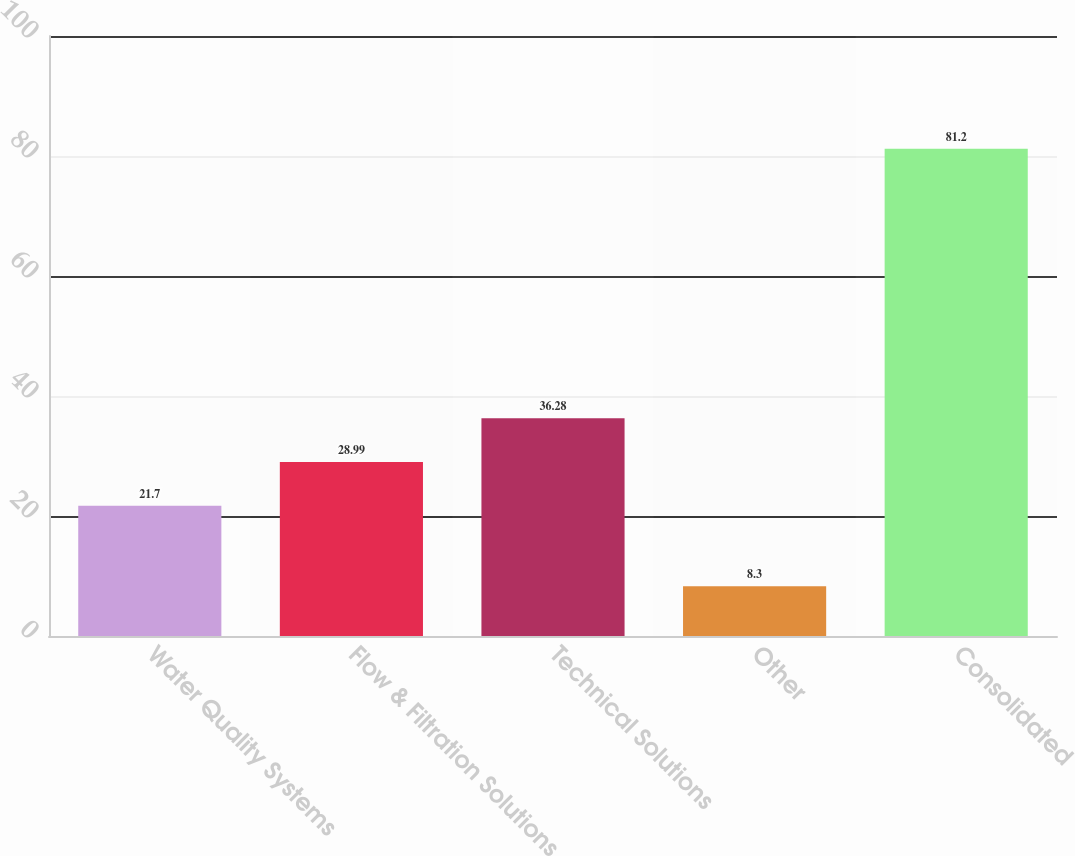Convert chart to OTSL. <chart><loc_0><loc_0><loc_500><loc_500><bar_chart><fcel>Water Quality Systems<fcel>Flow & Filtration Solutions<fcel>Technical Solutions<fcel>Other<fcel>Consolidated<nl><fcel>21.7<fcel>28.99<fcel>36.28<fcel>8.3<fcel>81.2<nl></chart> 